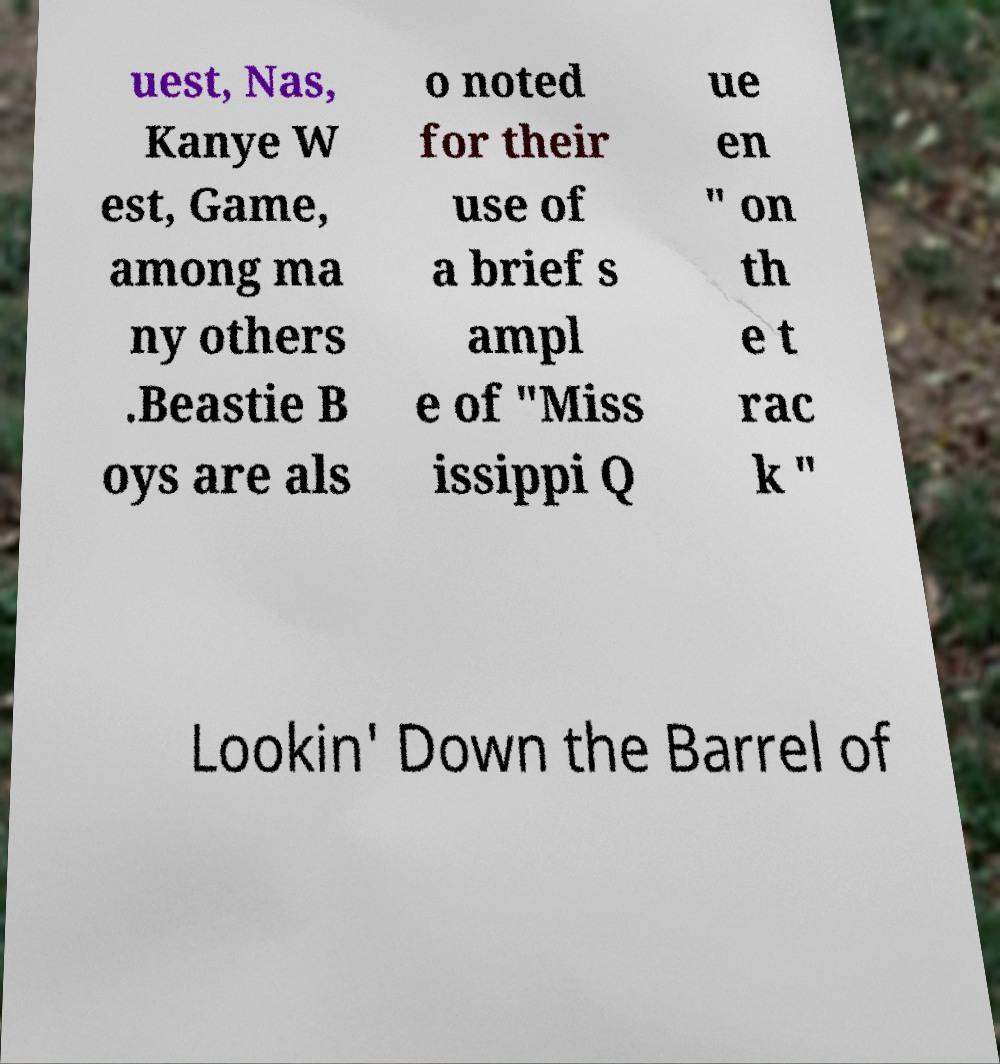Can you read and provide the text displayed in the image?This photo seems to have some interesting text. Can you extract and type it out for me? uest, Nas, Kanye W est, Game, among ma ny others .Beastie B oys are als o noted for their use of a brief s ampl e of "Miss issippi Q ue en " on th e t rac k " Lookin' Down the Barrel of 